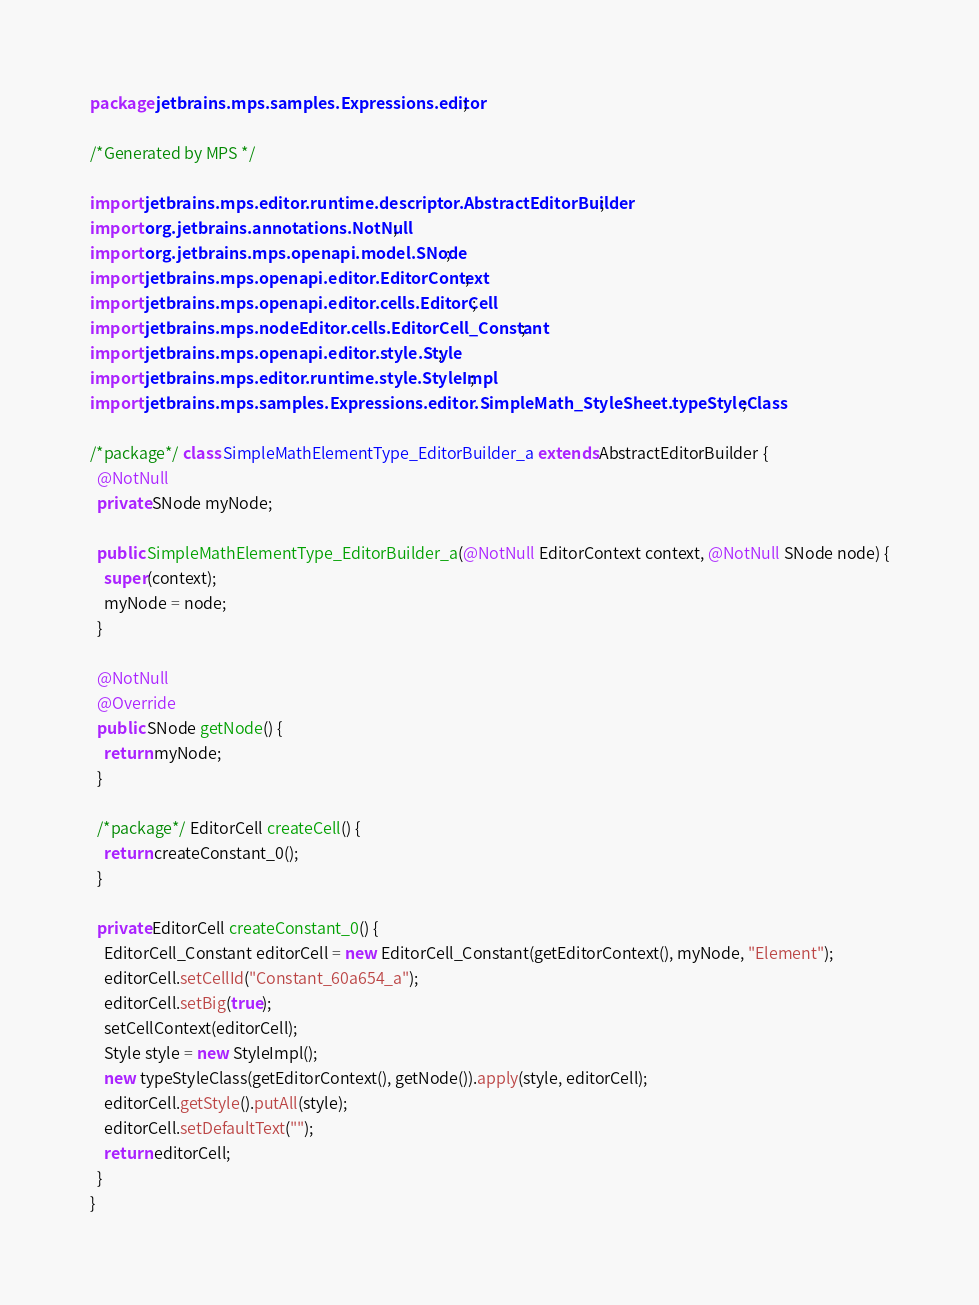Convert code to text. <code><loc_0><loc_0><loc_500><loc_500><_Java_>package jetbrains.mps.samples.Expressions.editor;

/*Generated by MPS */

import jetbrains.mps.editor.runtime.descriptor.AbstractEditorBuilder;
import org.jetbrains.annotations.NotNull;
import org.jetbrains.mps.openapi.model.SNode;
import jetbrains.mps.openapi.editor.EditorContext;
import jetbrains.mps.openapi.editor.cells.EditorCell;
import jetbrains.mps.nodeEditor.cells.EditorCell_Constant;
import jetbrains.mps.openapi.editor.style.Style;
import jetbrains.mps.editor.runtime.style.StyleImpl;
import jetbrains.mps.samples.Expressions.editor.SimpleMath_StyleSheet.typeStyleClass;

/*package*/ class SimpleMathElementType_EditorBuilder_a extends AbstractEditorBuilder {
  @NotNull
  private SNode myNode;

  public SimpleMathElementType_EditorBuilder_a(@NotNull EditorContext context, @NotNull SNode node) {
    super(context);
    myNode = node;
  }

  @NotNull
  @Override
  public SNode getNode() {
    return myNode;
  }

  /*package*/ EditorCell createCell() {
    return createConstant_0();
  }

  private EditorCell createConstant_0() {
    EditorCell_Constant editorCell = new EditorCell_Constant(getEditorContext(), myNode, "Element");
    editorCell.setCellId("Constant_60a654_a");
    editorCell.setBig(true);
    setCellContext(editorCell);
    Style style = new StyleImpl();
    new typeStyleClass(getEditorContext(), getNode()).apply(style, editorCell);
    editorCell.getStyle().putAll(style);
    editorCell.setDefaultText("");
    return editorCell;
  }
}
</code> 